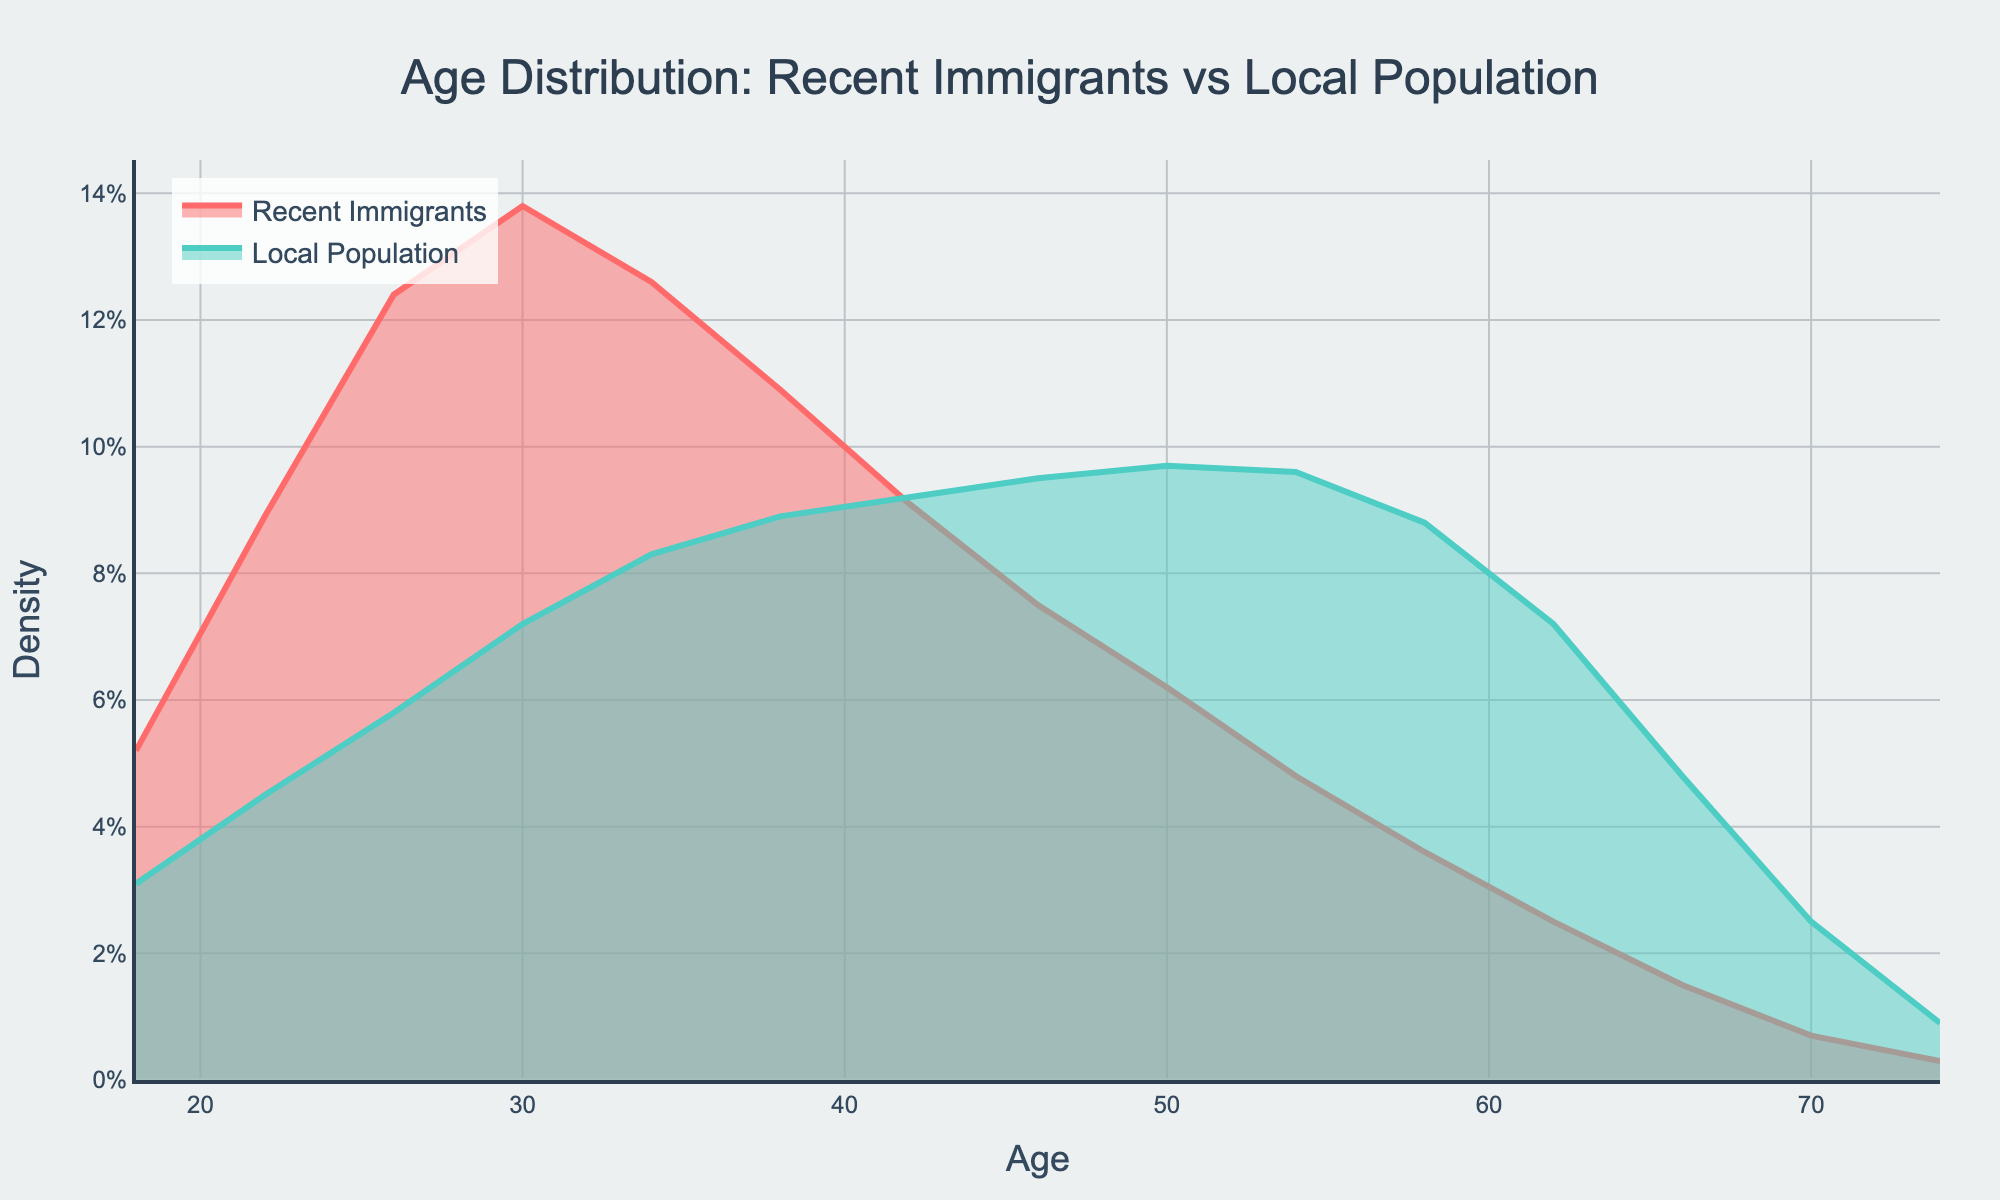What is the title of the density plot? The title is usually positioned at the top center of the plot. It provides a brief description of what the plot represents, which helps in understanding the context of the visualized data.
Answer: Age Distribution: Recent Immigrants vs Local Population What age group has the highest density for recent immigrants? To determine this, look for the peak point in the line associated with recent immigrants. The age at which this peak occurs represents the highest density.
Answer: 30 How does the density of local population change from age 18 to age 26? Observe the line corresponding to the local population from age 18 to 26. Compare the density values at these points to understand the change.
Answer: It increases Between ages 30 and 42, which group has a higher density? Compare the values of the density plots for recent immigrants and the local population between the specified ages. Identify which line (color) represents higher density more frequently within this range.
Answer: Recent immigrants What is the general trend of the density for recent immigrants after age 38? Look at the line for recent immigrants starting from age 38 and moving towards the older ages. Identify the trend whether it's increasing, decreasing, or stable.
Answer: Decreasing At what age do the densities for recent immigrants and local population become roughly equal? Identify the point on the plot where the lines for recent immigrants and local population intersect or come very close, indicating similar densities.
Answer: 42 What age group has the lowest density for the local population? Find the point at which the line corresponding to the local population is at its minimum, indicating the lowest density for a particular age group.
Answer: 74 Comparing ages 62 and 66, for which age does the recent immigrant group have a higher relative density? Examine the density values for recent immigrants at ages 62 and 66. Determine which age has a greater density.
Answer: 62 By how much does the density for recent immigrants decrease from age 26 to age 50? Check the density value for recent immigrants at ages 26 and 50. Subtract the density at age 50 from the density at age 26 to get the decrease.
Answer: 0.124 - 0.062 = 0.062 Is the density for the local population higher than that for recent immigrants at age 70? Compare the density values at age 70 for both local population and recent immigrants. Determine if the local population's density is higher.
Answer: Yes 